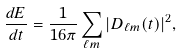<formula> <loc_0><loc_0><loc_500><loc_500>\frac { d E } { d t } = \frac { 1 } { 1 6 \pi } \sum _ { \ell m } { | D _ { \ell m } ( t ) | ^ { 2 } } ,</formula> 